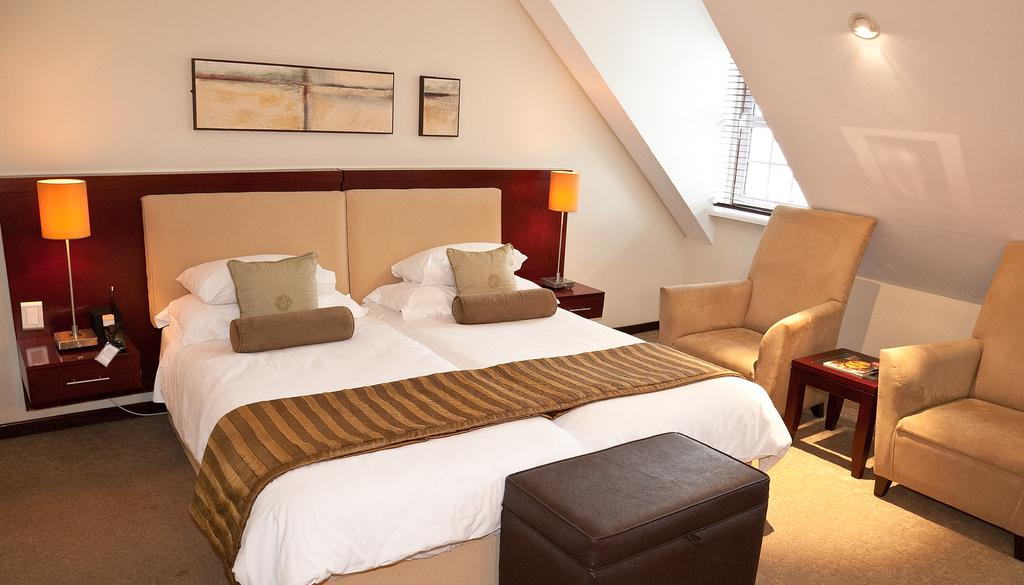What is the main object in the middle of the image? There is a bed in the middle of the image. What items are on the bed? There are pillows and a bed sheet on the bed. What furniture can be seen on the right side of the image? There are two chairs on the right side of the image. What other objects are present in the image? There is a table, a light, a wall, a photo frame, and another light in the background of the image. What is the chance of winning a prize in the image? There is no mention of a prize or any game of chance in the image. What type of wire is used to connect the lights in the image? The image does not show the wiring or connections of the lights, so it cannot be determined from the image. 